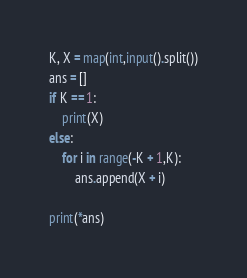Convert code to text. <code><loc_0><loc_0><loc_500><loc_500><_Python_>K, X = map(int,input().split())
ans = []
if K == 1:
    print(X)
else:
    for i in range(-K + 1,K):
        ans.append(X + i)

print(*ans)
</code> 